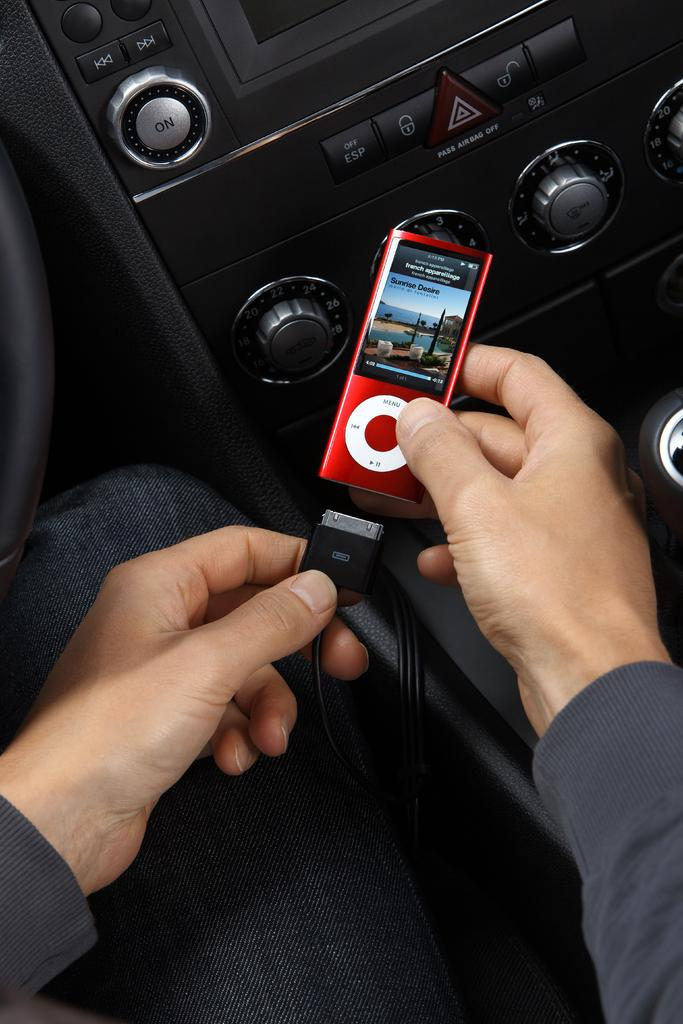Who is present in the image? There is a person in the image. What is the person holding in the image? The person is holding an iPod. What can be found in the vehicle in the image? There is a music system in the vehicle. What type of science experiment is being conducted in the image? There is no science experiment present in the image; it features a person holding an iPod and a music system in a vehicle. What color is the wire used to crush the object in the image? There is no wire or object being crushed in the image. 